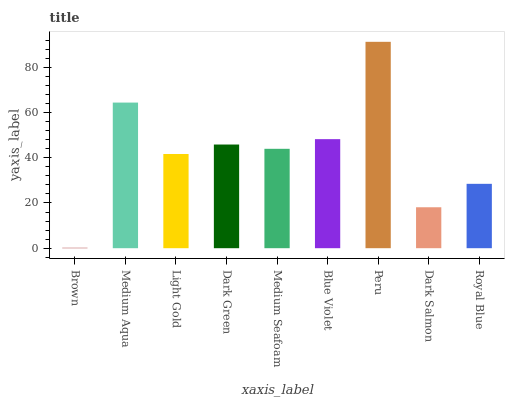Is Brown the minimum?
Answer yes or no. Yes. Is Peru the maximum?
Answer yes or no. Yes. Is Medium Aqua the minimum?
Answer yes or no. No. Is Medium Aqua the maximum?
Answer yes or no. No. Is Medium Aqua greater than Brown?
Answer yes or no. Yes. Is Brown less than Medium Aqua?
Answer yes or no. Yes. Is Brown greater than Medium Aqua?
Answer yes or no. No. Is Medium Aqua less than Brown?
Answer yes or no. No. Is Medium Seafoam the high median?
Answer yes or no. Yes. Is Medium Seafoam the low median?
Answer yes or no. Yes. Is Blue Violet the high median?
Answer yes or no. No. Is Blue Violet the low median?
Answer yes or no. No. 